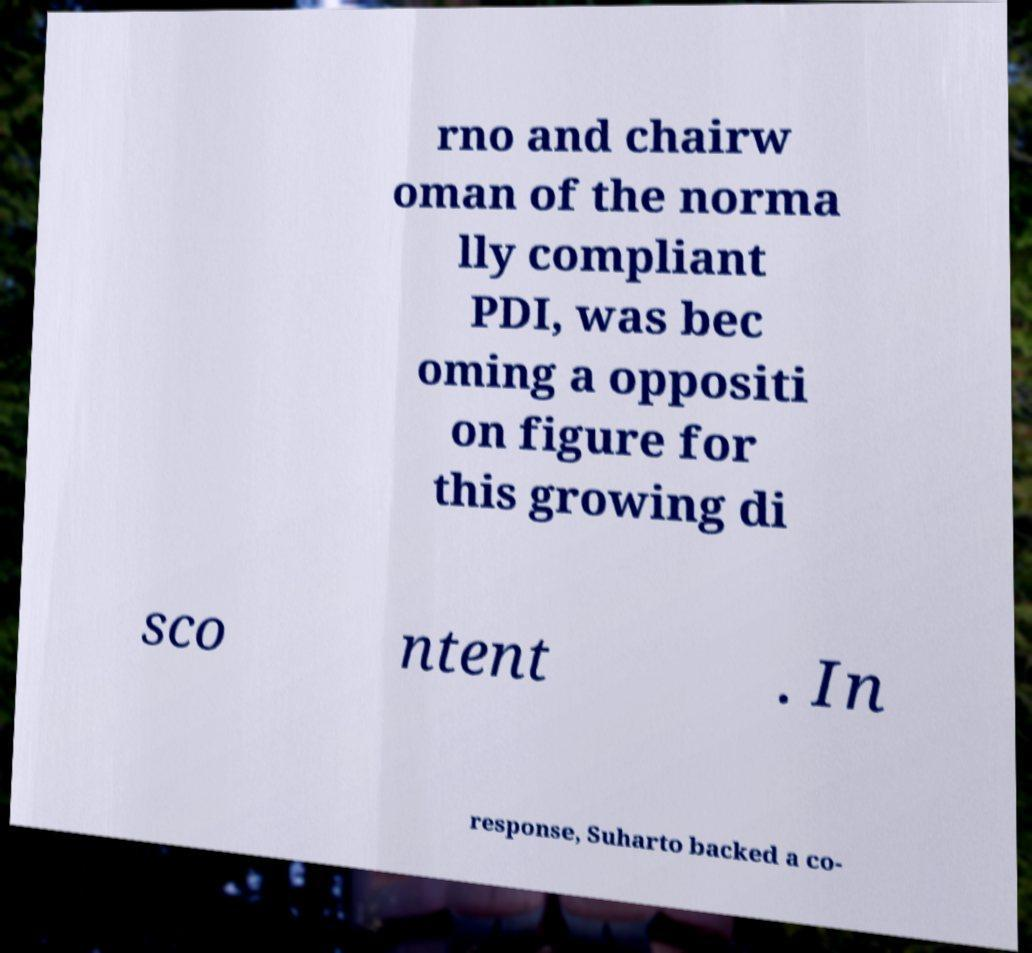Can you read and provide the text displayed in the image?This photo seems to have some interesting text. Can you extract and type it out for me? rno and chairw oman of the norma lly compliant PDI, was bec oming a oppositi on figure for this growing di sco ntent . In response, Suharto backed a co- 